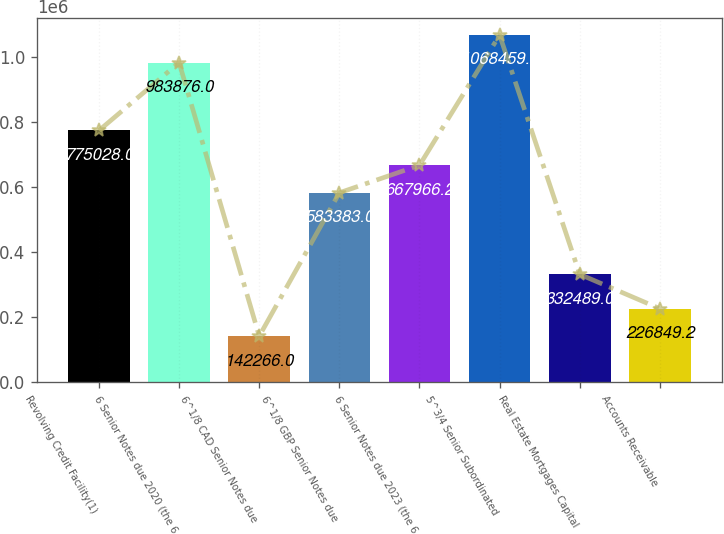Convert chart to OTSL. <chart><loc_0><loc_0><loc_500><loc_500><bar_chart><fcel>Revolving Credit Facility(1)<fcel>6 Senior Notes due 2020 (the 6<fcel>6^1/8 CAD Senior Notes due<fcel>6^1/8 GBP Senior Notes due<fcel>6 Senior Notes due 2023 (the 6<fcel>5^3/4 Senior Subordinated<fcel>Real Estate Mortgages Capital<fcel>Accounts Receivable<nl><fcel>775028<fcel>983876<fcel>142266<fcel>583383<fcel>667966<fcel>1.06846e+06<fcel>332489<fcel>226849<nl></chart> 